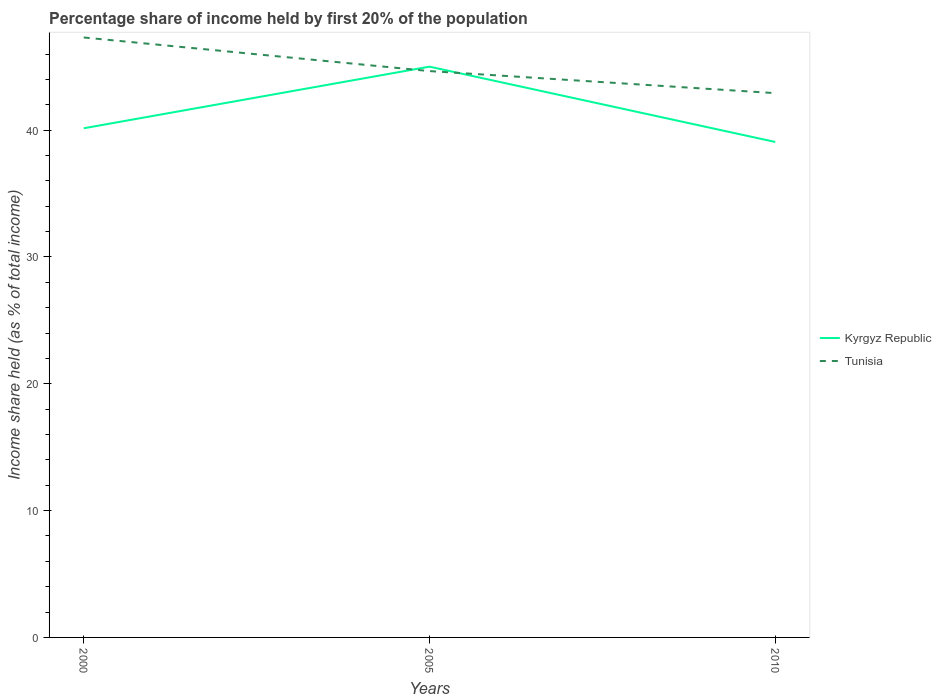Across all years, what is the maximum share of income held by first 20% of the population in Kyrgyz Republic?
Make the answer very short. 39.07. What is the total share of income held by first 20% of the population in Tunisia in the graph?
Your answer should be very brief. 4.39. What is the difference between the highest and the second highest share of income held by first 20% of the population in Tunisia?
Your answer should be very brief. 4.39. What is the difference between two consecutive major ticks on the Y-axis?
Your response must be concise. 10. Are the values on the major ticks of Y-axis written in scientific E-notation?
Your answer should be compact. No. Does the graph contain any zero values?
Your answer should be very brief. No. How are the legend labels stacked?
Keep it short and to the point. Vertical. What is the title of the graph?
Keep it short and to the point. Percentage share of income held by first 20% of the population. Does "Seychelles" appear as one of the legend labels in the graph?
Offer a very short reply. No. What is the label or title of the Y-axis?
Keep it short and to the point. Income share held (as % of total income). What is the Income share held (as % of total income) of Kyrgyz Republic in 2000?
Offer a terse response. 40.15. What is the Income share held (as % of total income) of Tunisia in 2000?
Your response must be concise. 47.31. What is the Income share held (as % of total income) of Kyrgyz Republic in 2005?
Ensure brevity in your answer.  45.01. What is the Income share held (as % of total income) of Tunisia in 2005?
Your answer should be compact. 44.66. What is the Income share held (as % of total income) in Kyrgyz Republic in 2010?
Your answer should be very brief. 39.07. What is the Income share held (as % of total income) in Tunisia in 2010?
Offer a terse response. 42.92. Across all years, what is the maximum Income share held (as % of total income) of Kyrgyz Republic?
Your answer should be very brief. 45.01. Across all years, what is the maximum Income share held (as % of total income) in Tunisia?
Make the answer very short. 47.31. Across all years, what is the minimum Income share held (as % of total income) in Kyrgyz Republic?
Offer a terse response. 39.07. Across all years, what is the minimum Income share held (as % of total income) in Tunisia?
Make the answer very short. 42.92. What is the total Income share held (as % of total income) of Kyrgyz Republic in the graph?
Give a very brief answer. 124.23. What is the total Income share held (as % of total income) of Tunisia in the graph?
Provide a short and direct response. 134.89. What is the difference between the Income share held (as % of total income) of Kyrgyz Republic in 2000 and that in 2005?
Keep it short and to the point. -4.86. What is the difference between the Income share held (as % of total income) in Tunisia in 2000 and that in 2005?
Offer a terse response. 2.65. What is the difference between the Income share held (as % of total income) in Kyrgyz Republic in 2000 and that in 2010?
Your answer should be very brief. 1.08. What is the difference between the Income share held (as % of total income) of Tunisia in 2000 and that in 2010?
Your response must be concise. 4.39. What is the difference between the Income share held (as % of total income) in Kyrgyz Republic in 2005 and that in 2010?
Offer a very short reply. 5.94. What is the difference between the Income share held (as % of total income) of Tunisia in 2005 and that in 2010?
Offer a terse response. 1.74. What is the difference between the Income share held (as % of total income) of Kyrgyz Republic in 2000 and the Income share held (as % of total income) of Tunisia in 2005?
Offer a very short reply. -4.51. What is the difference between the Income share held (as % of total income) of Kyrgyz Republic in 2000 and the Income share held (as % of total income) of Tunisia in 2010?
Your answer should be very brief. -2.77. What is the difference between the Income share held (as % of total income) of Kyrgyz Republic in 2005 and the Income share held (as % of total income) of Tunisia in 2010?
Ensure brevity in your answer.  2.09. What is the average Income share held (as % of total income) in Kyrgyz Republic per year?
Offer a very short reply. 41.41. What is the average Income share held (as % of total income) in Tunisia per year?
Offer a terse response. 44.96. In the year 2000, what is the difference between the Income share held (as % of total income) of Kyrgyz Republic and Income share held (as % of total income) of Tunisia?
Provide a short and direct response. -7.16. In the year 2005, what is the difference between the Income share held (as % of total income) in Kyrgyz Republic and Income share held (as % of total income) in Tunisia?
Give a very brief answer. 0.35. In the year 2010, what is the difference between the Income share held (as % of total income) in Kyrgyz Republic and Income share held (as % of total income) in Tunisia?
Your response must be concise. -3.85. What is the ratio of the Income share held (as % of total income) of Kyrgyz Republic in 2000 to that in 2005?
Give a very brief answer. 0.89. What is the ratio of the Income share held (as % of total income) of Tunisia in 2000 to that in 2005?
Keep it short and to the point. 1.06. What is the ratio of the Income share held (as % of total income) of Kyrgyz Republic in 2000 to that in 2010?
Your response must be concise. 1.03. What is the ratio of the Income share held (as % of total income) in Tunisia in 2000 to that in 2010?
Provide a succinct answer. 1.1. What is the ratio of the Income share held (as % of total income) in Kyrgyz Republic in 2005 to that in 2010?
Your response must be concise. 1.15. What is the ratio of the Income share held (as % of total income) of Tunisia in 2005 to that in 2010?
Ensure brevity in your answer.  1.04. What is the difference between the highest and the second highest Income share held (as % of total income) in Kyrgyz Republic?
Ensure brevity in your answer.  4.86. What is the difference between the highest and the second highest Income share held (as % of total income) of Tunisia?
Ensure brevity in your answer.  2.65. What is the difference between the highest and the lowest Income share held (as % of total income) of Kyrgyz Republic?
Make the answer very short. 5.94. What is the difference between the highest and the lowest Income share held (as % of total income) in Tunisia?
Give a very brief answer. 4.39. 